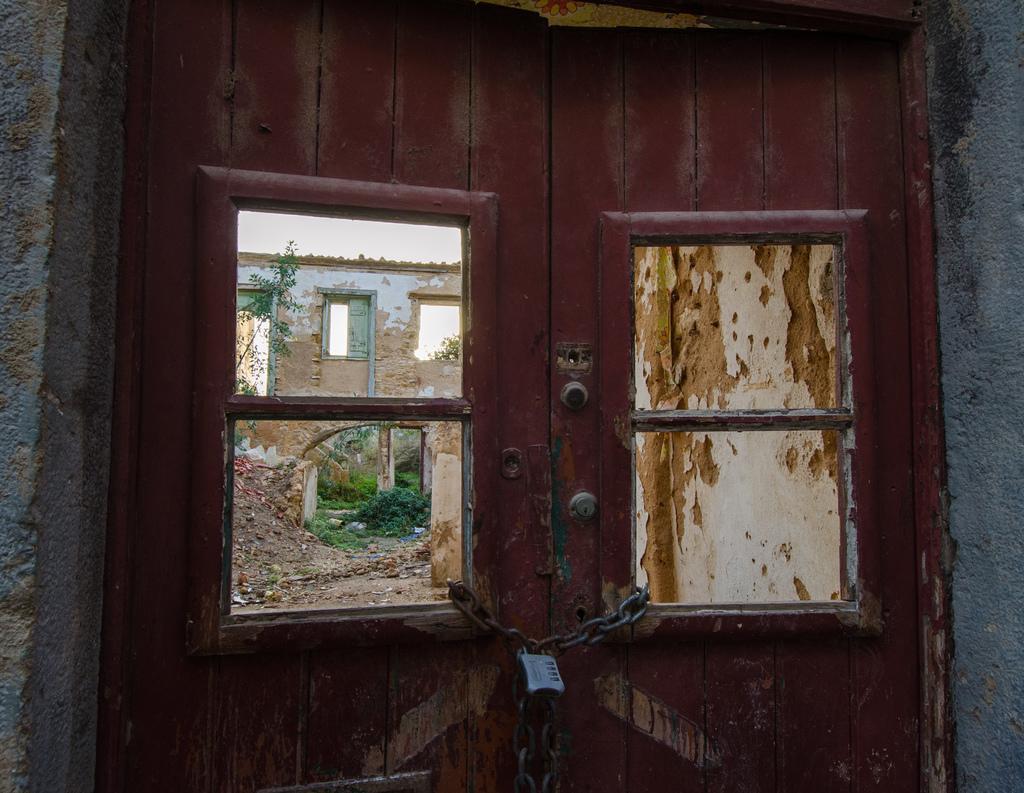In one or two sentences, can you explain what this image depicts? In this image we can see the doors locked, through the doors we can see a building, windows, plants, grass and the wall. 